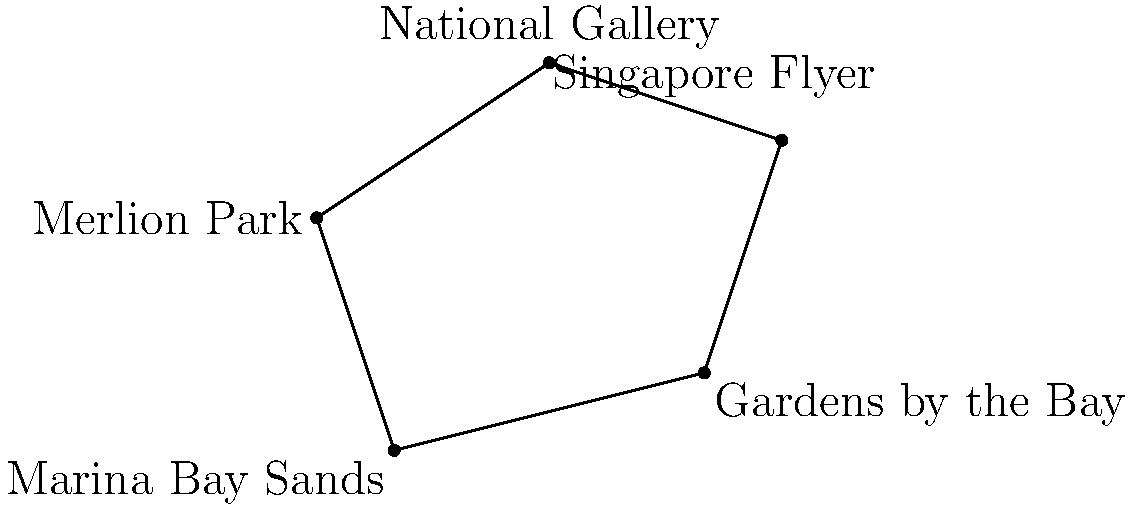In the map above, five iconic landmarks of Singapore are connected to form a polygon. If each unit on the map represents 1 km, what is the area of this polygon in square kilometers? To find the area of this irregular polygon, we can use the Shoelace formula (also known as the surveyor's formula). The steps are as follows:

1) First, we need to identify the coordinates of each point:
   A (0,0), B (4,1), C (5,4), D (2,5), E (-1,3)

2) The Shoelace formula for a polygon with vertices $(x_1, y_1), (x_2, y_2), ..., (x_n, y_n)$ is:

   $$ \text{Area} = \frac{1}{2}|(x_1y_2 + x_2y_3 + ... + x_ny_1) - (y_1x_2 + y_2x_3 + ... + y_nx_1)| $$

3) Applying this formula to our polygon:

   $$ \text{Area} = \frac{1}{2}|[(0 \cdot 1 + 4 \cdot 4 + 5 \cdot 5 + 2 \cdot 3 + (-1) \cdot 0) - (0 \cdot 4 + 1 \cdot 5 + 4 \cdot 2 + 5 \cdot (-1) + 3 \cdot 0)]| $$

4) Simplifying:

   $$ \text{Area} = \frac{1}{2}|(0 + 16 + 25 + 6 + 0) - (0 + 5 + 8 - 5 + 0)| $$
   $$ = \frac{1}{2}|47 - 8| = \frac{1}{2} \cdot 39 = 19.5 $$

5) Since each unit represents 1 km, the area is 19.5 square kilometers.
Answer: 19.5 km² 